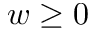Convert formula to latex. <formula><loc_0><loc_0><loc_500><loc_500>w \geq 0</formula> 